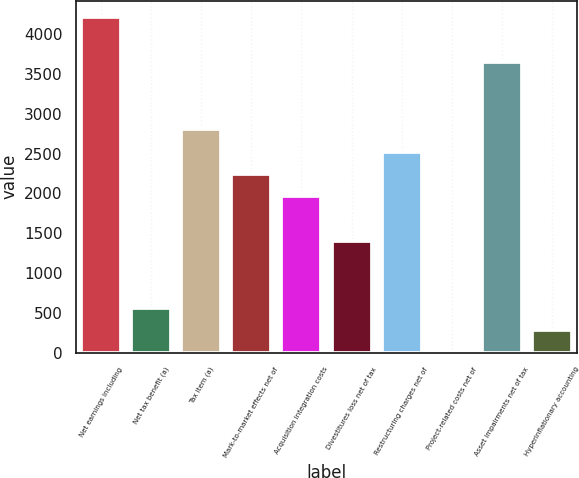<chart> <loc_0><loc_0><loc_500><loc_500><bar_chart><fcel>Net earnings including<fcel>Net tax benefit (a)<fcel>Tax item (a)<fcel>Mark-to-market effects net of<fcel>Acquisition integration costs<fcel>Divestitures loss net of tax<fcel>Restructuring charges net of<fcel>Project-related costs net of<fcel>Asset impairments net of tax<fcel>Hyperinflationary accounting<nl><fcel>4209.95<fcel>562.28<fcel>2807<fcel>2245.82<fcel>1965.23<fcel>1404.05<fcel>2526.41<fcel>1.1<fcel>3648.77<fcel>281.69<nl></chart> 